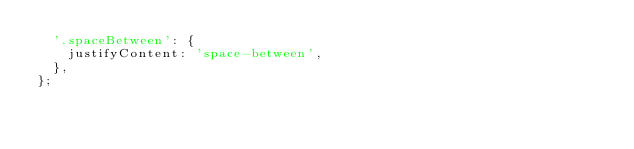<code> <loc_0><loc_0><loc_500><loc_500><_JavaScript_>  '.spaceBetween': {
    justifyContent: 'space-between',
  },
};
</code> 